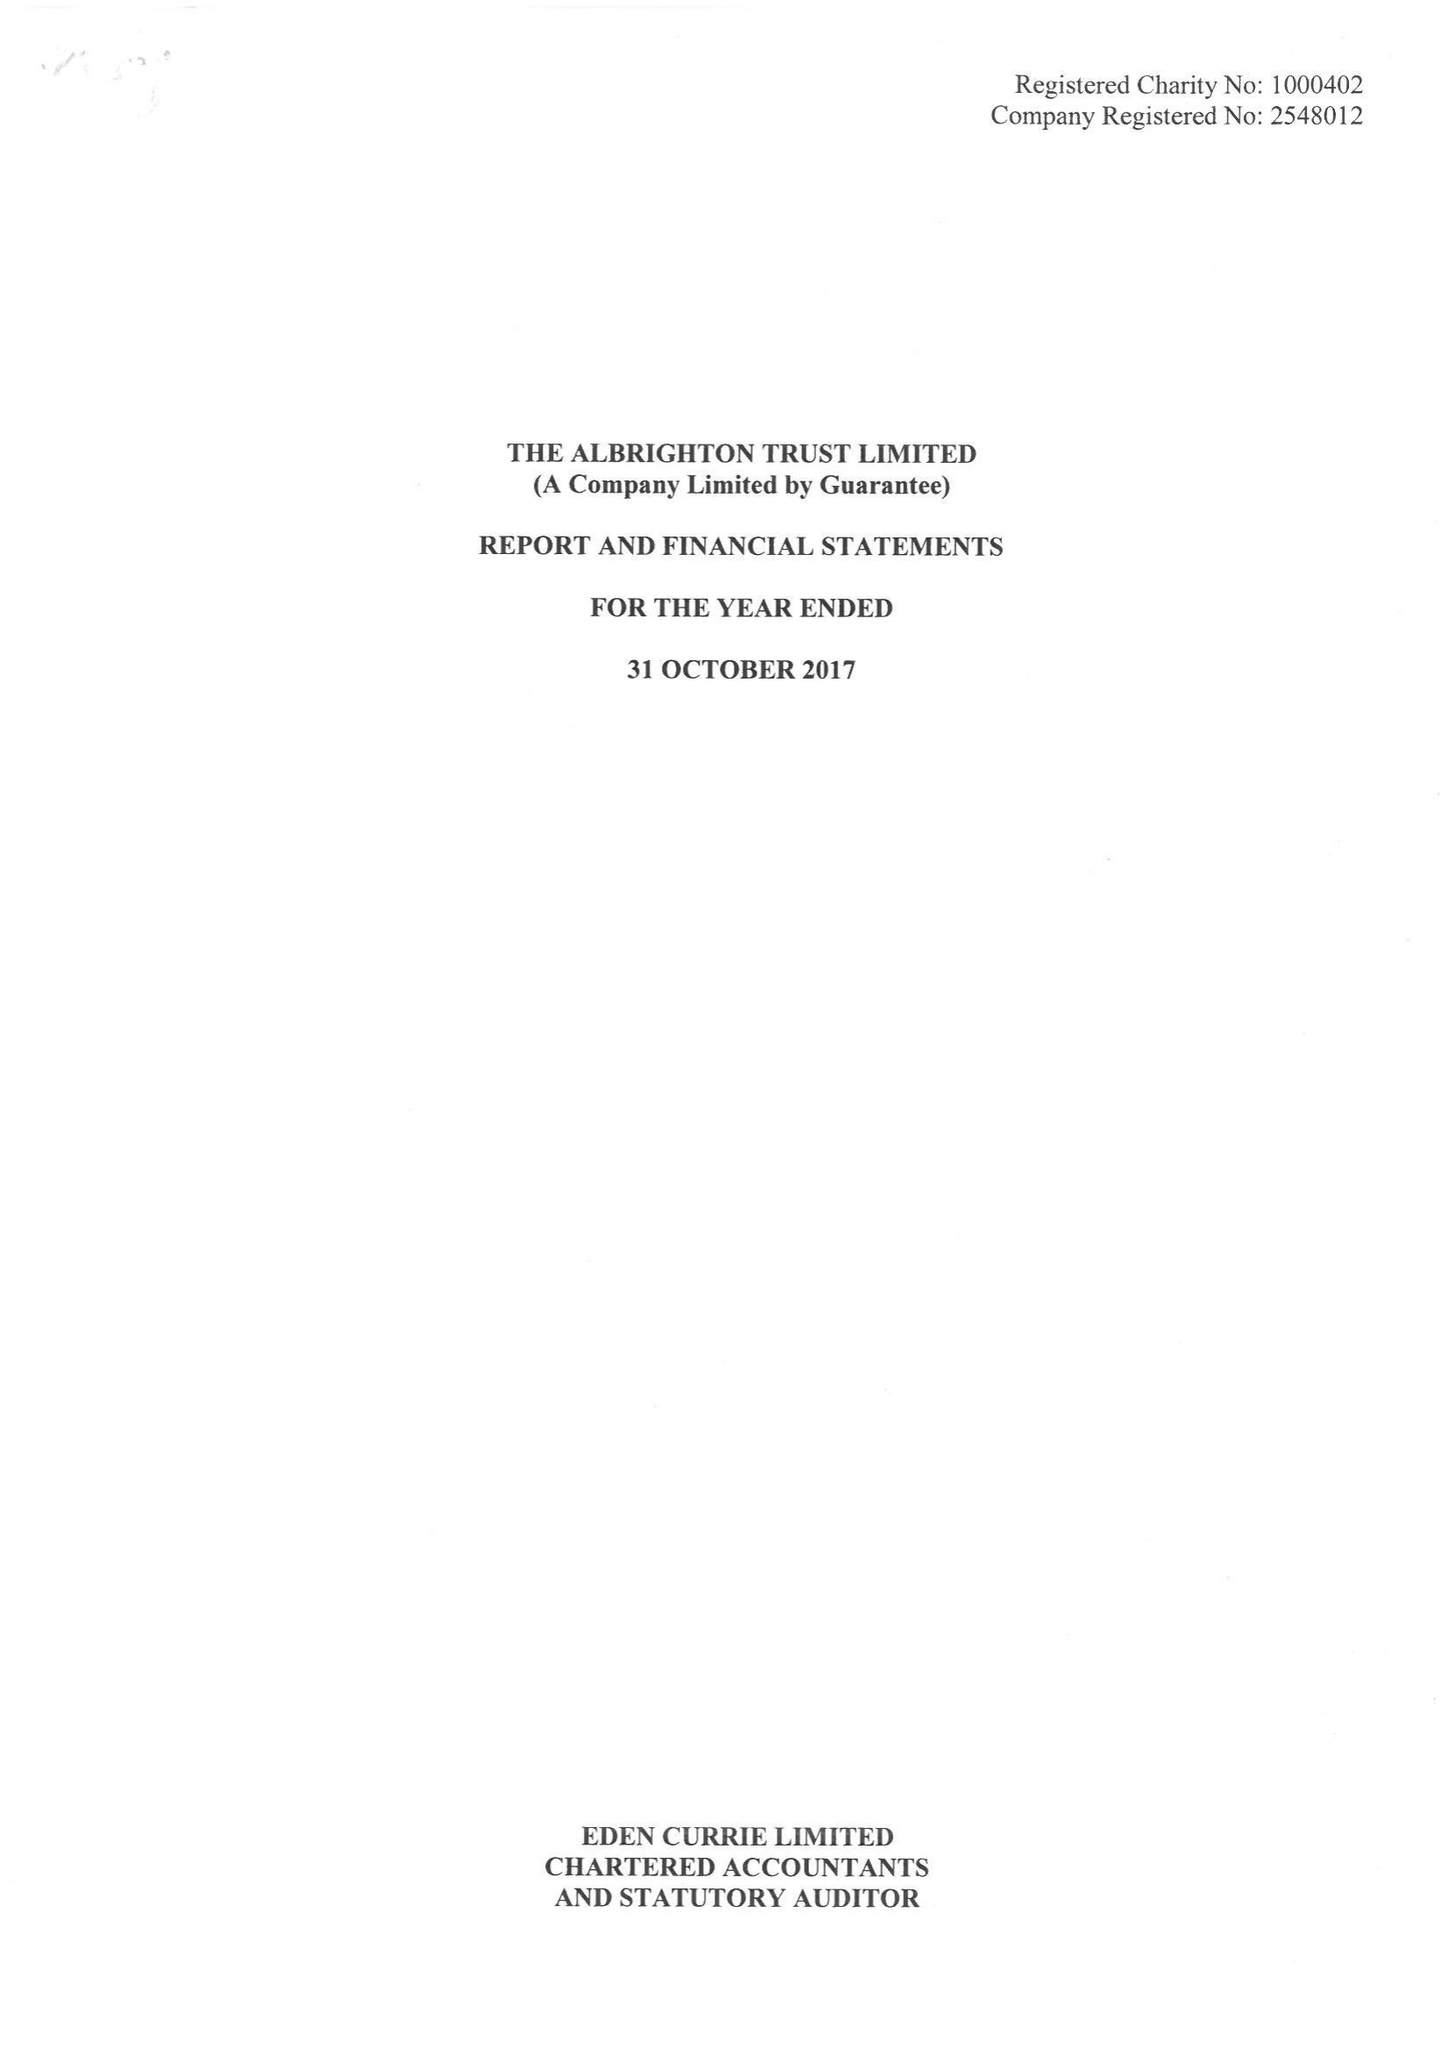What is the value for the spending_annually_in_british_pounds?
Answer the question using a single word or phrase. 185068.00 